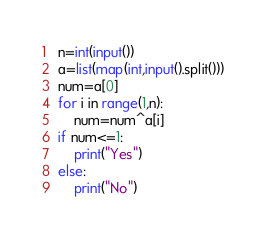Convert code to text. <code><loc_0><loc_0><loc_500><loc_500><_Python_>n=int(input())
a=list(map(int,input().split()))
num=a[0]
for i in range(1,n):
    num=num^a[i]
if num<=1:
    print("Yes")
else:
    print("No")
</code> 